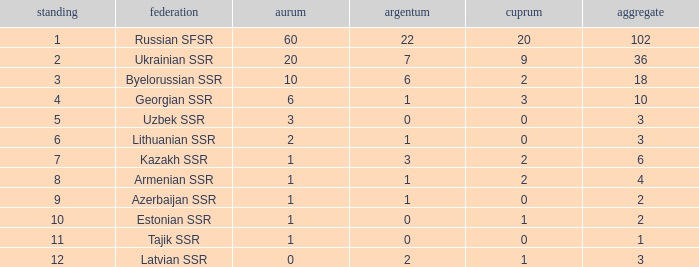Could you parse the entire table? {'header': ['standing', 'federation', 'aurum', 'argentum', 'cuprum', 'aggregate'], 'rows': [['1', 'Russian SFSR', '60', '22', '20', '102'], ['2', 'Ukrainian SSR', '20', '7', '9', '36'], ['3', 'Byelorussian SSR', '10', '6', '2', '18'], ['4', 'Georgian SSR', '6', '1', '3', '10'], ['5', 'Uzbek SSR', '3', '0', '0', '3'], ['6', 'Lithuanian SSR', '2', '1', '0', '3'], ['7', 'Kazakh SSR', '1', '3', '2', '6'], ['8', 'Armenian SSR', '1', '1', '2', '4'], ['9', 'Azerbaijan SSR', '1', '1', '0', '2'], ['10', 'Estonian SSR', '1', '0', '1', '2'], ['11', 'Tajik SSR', '1', '0', '0', '1'], ['12', 'Latvian SSR', '0', '2', '1', '3']]} What is the average total for teams with more than 1 gold, ranked over 3 and more than 3 bronze? None. 